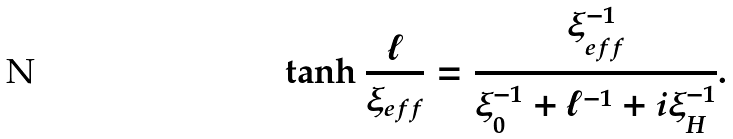<formula> <loc_0><loc_0><loc_500><loc_500>\tanh \frac { \ell } { \xi _ { e f f } } = \frac { \xi _ { e f f } ^ { - 1 } } { \xi _ { 0 } ^ { - 1 } + \ell ^ { - 1 } + i \xi _ { H } ^ { - 1 } } .</formula> 